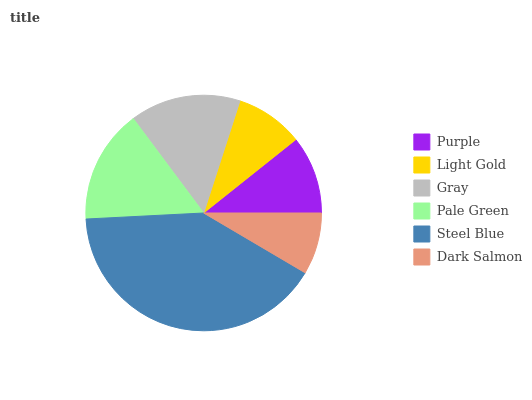Is Dark Salmon the minimum?
Answer yes or no. Yes. Is Steel Blue the maximum?
Answer yes or no. Yes. Is Light Gold the minimum?
Answer yes or no. No. Is Light Gold the maximum?
Answer yes or no. No. Is Purple greater than Light Gold?
Answer yes or no. Yes. Is Light Gold less than Purple?
Answer yes or no. Yes. Is Light Gold greater than Purple?
Answer yes or no. No. Is Purple less than Light Gold?
Answer yes or no. No. Is Gray the high median?
Answer yes or no. Yes. Is Purple the low median?
Answer yes or no. Yes. Is Pale Green the high median?
Answer yes or no. No. Is Gray the low median?
Answer yes or no. No. 